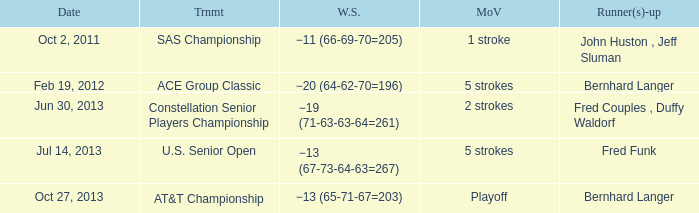Which Date has a Runner(s)-up of fred funk? Jul 14, 2013. 